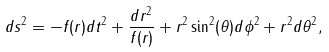Convert formula to latex. <formula><loc_0><loc_0><loc_500><loc_500>d s ^ { 2 } = - f ( r ) d t ^ { 2 } + \frac { d r ^ { 2 } } { f ( r ) } + r ^ { 2 } \sin ^ { 2 } ( \theta ) d \phi ^ { 2 } + r ^ { 2 } d \theta ^ { 2 } ,</formula> 